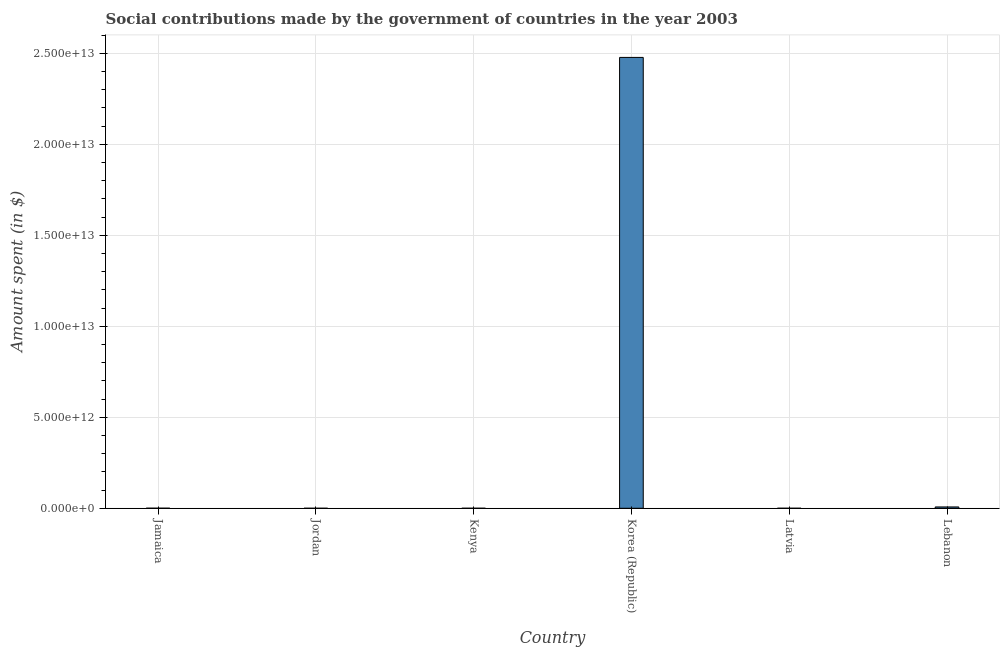Does the graph contain grids?
Your answer should be very brief. Yes. What is the title of the graph?
Provide a succinct answer. Social contributions made by the government of countries in the year 2003. What is the label or title of the Y-axis?
Provide a short and direct response. Amount spent (in $). What is the amount spent in making social contributions in Latvia?
Your answer should be very brief. 5.62e+08. Across all countries, what is the maximum amount spent in making social contributions?
Provide a short and direct response. 2.48e+13. Across all countries, what is the minimum amount spent in making social contributions?
Provide a succinct answer. 1.90e+07. In which country was the amount spent in making social contributions maximum?
Your answer should be very brief. Korea (Republic). In which country was the amount spent in making social contributions minimum?
Ensure brevity in your answer.  Jordan. What is the sum of the amount spent in making social contributions?
Provide a short and direct response. 2.48e+13. What is the difference between the amount spent in making social contributions in Jordan and Kenya?
Provide a succinct answer. -4.41e+08. What is the average amount spent in making social contributions per country?
Give a very brief answer. 4.14e+12. What is the median amount spent in making social contributions?
Your response must be concise. 2.03e+09. In how many countries, is the amount spent in making social contributions greater than 22000000000000 $?
Make the answer very short. 1. Is the difference between the amount spent in making social contributions in Jordan and Kenya greater than the difference between any two countries?
Your answer should be compact. No. What is the difference between the highest and the second highest amount spent in making social contributions?
Ensure brevity in your answer.  2.47e+13. Is the sum of the amount spent in making social contributions in Jamaica and Korea (Republic) greater than the maximum amount spent in making social contributions across all countries?
Offer a very short reply. Yes. What is the difference between the highest and the lowest amount spent in making social contributions?
Give a very brief answer. 2.48e+13. In how many countries, is the amount spent in making social contributions greater than the average amount spent in making social contributions taken over all countries?
Make the answer very short. 1. How many countries are there in the graph?
Make the answer very short. 6. What is the difference between two consecutive major ticks on the Y-axis?
Your answer should be compact. 5.00e+12. Are the values on the major ticks of Y-axis written in scientific E-notation?
Your response must be concise. Yes. What is the Amount spent (in $) of Jamaica?
Your answer should be very brief. 3.49e+09. What is the Amount spent (in $) of Jordan?
Your answer should be very brief. 1.90e+07. What is the Amount spent (in $) in Kenya?
Your answer should be compact. 4.60e+08. What is the Amount spent (in $) of Korea (Republic)?
Your response must be concise. 2.48e+13. What is the Amount spent (in $) of Latvia?
Ensure brevity in your answer.  5.62e+08. What is the Amount spent (in $) in Lebanon?
Ensure brevity in your answer.  7.27e+1. What is the difference between the Amount spent (in $) in Jamaica and Jordan?
Give a very brief answer. 3.47e+09. What is the difference between the Amount spent (in $) in Jamaica and Kenya?
Offer a very short reply. 3.03e+09. What is the difference between the Amount spent (in $) in Jamaica and Korea (Republic)?
Your answer should be very brief. -2.48e+13. What is the difference between the Amount spent (in $) in Jamaica and Latvia?
Provide a short and direct response. 2.93e+09. What is the difference between the Amount spent (in $) in Jamaica and Lebanon?
Provide a succinct answer. -6.92e+1. What is the difference between the Amount spent (in $) in Jordan and Kenya?
Provide a short and direct response. -4.41e+08. What is the difference between the Amount spent (in $) in Jordan and Korea (Republic)?
Ensure brevity in your answer.  -2.48e+13. What is the difference between the Amount spent (in $) in Jordan and Latvia?
Provide a succinct answer. -5.43e+08. What is the difference between the Amount spent (in $) in Jordan and Lebanon?
Keep it short and to the point. -7.27e+1. What is the difference between the Amount spent (in $) in Kenya and Korea (Republic)?
Offer a very short reply. -2.48e+13. What is the difference between the Amount spent (in $) in Kenya and Latvia?
Your response must be concise. -1.02e+08. What is the difference between the Amount spent (in $) in Kenya and Lebanon?
Your response must be concise. -7.22e+1. What is the difference between the Amount spent (in $) in Korea (Republic) and Latvia?
Offer a terse response. 2.48e+13. What is the difference between the Amount spent (in $) in Korea (Republic) and Lebanon?
Keep it short and to the point. 2.47e+13. What is the difference between the Amount spent (in $) in Latvia and Lebanon?
Your answer should be very brief. -7.21e+1. What is the ratio of the Amount spent (in $) in Jamaica to that in Jordan?
Provide a short and direct response. 184.13. What is the ratio of the Amount spent (in $) in Jamaica to that in Kenya?
Your answer should be compact. 7.59. What is the ratio of the Amount spent (in $) in Jamaica to that in Latvia?
Offer a very short reply. 6.21. What is the ratio of the Amount spent (in $) in Jamaica to that in Lebanon?
Keep it short and to the point. 0.05. What is the ratio of the Amount spent (in $) in Jordan to that in Kenya?
Your response must be concise. 0.04. What is the ratio of the Amount spent (in $) in Jordan to that in Korea (Republic)?
Your answer should be compact. 0. What is the ratio of the Amount spent (in $) in Jordan to that in Latvia?
Offer a very short reply. 0.03. What is the ratio of the Amount spent (in $) in Kenya to that in Latvia?
Offer a very short reply. 0.82. What is the ratio of the Amount spent (in $) in Kenya to that in Lebanon?
Your answer should be compact. 0.01. What is the ratio of the Amount spent (in $) in Korea (Republic) to that in Latvia?
Provide a succinct answer. 4.41e+04. What is the ratio of the Amount spent (in $) in Korea (Republic) to that in Lebanon?
Provide a succinct answer. 340.7. What is the ratio of the Amount spent (in $) in Latvia to that in Lebanon?
Ensure brevity in your answer.  0.01. 